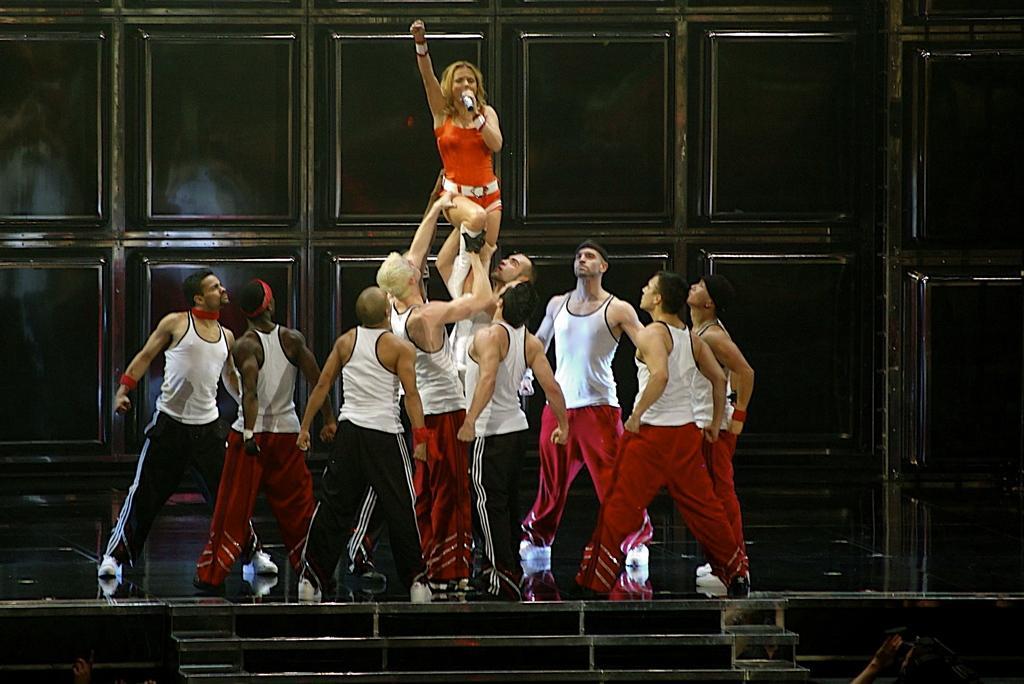Can you describe this image briefly? In this picture I can see that are a group of people standing here and some of them are holding and lifting the woman, she is holding a microphone and singing and in the backdrop there is a black color wall. 